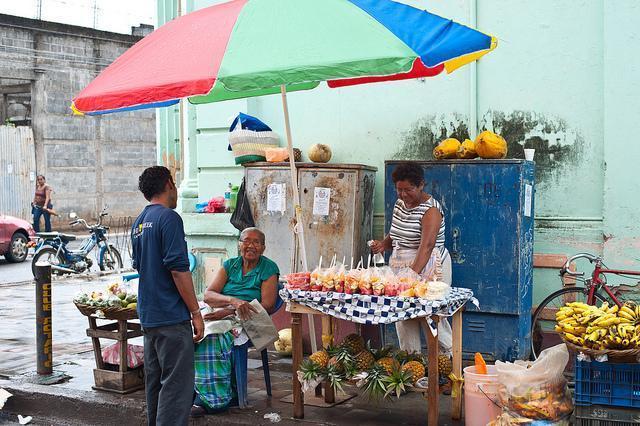Does the image validate the caption "The umbrella is attached to the bicycle."?
Answer yes or no. No. 